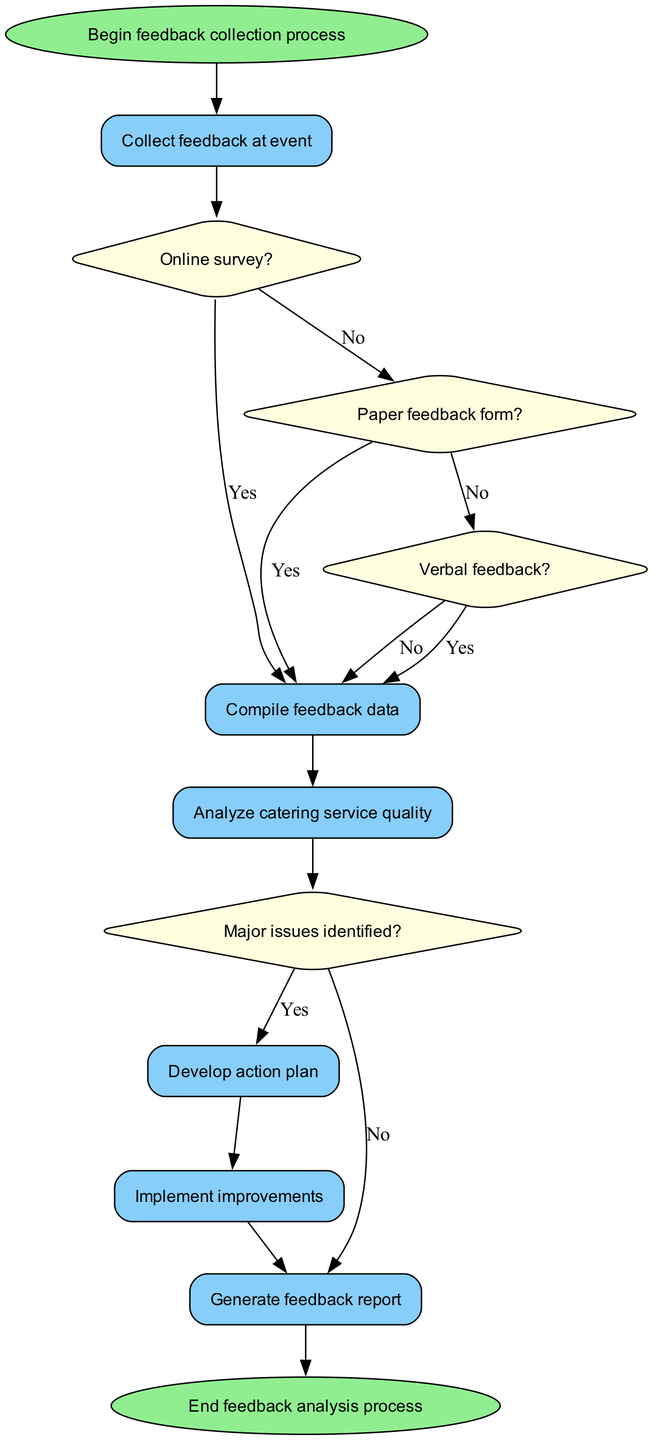What is the first step in the feedback collection process? The diagram starts with the node labeled "Begin feedback collection process," which indicates the initial action to take.
Answer: Begin feedback collection process How many methods are available for collecting feedback? The diagram lists three methods for collecting feedback: online survey, paper feedback form, and verbal feedback. By counting the methods, we find there are three distinct options.
Answer: 3 What happens if major issues are identified during the analysis? According to the flowchart, if major issues are identified, the next action taken is to develop an action plan, as indicated by the "Yes" label leading to the action node.
Answer: Develop action plan What is the process that follows the compilation of feedback data? After the "Compile feedback data" process, the next step is to "Analyze catering service quality," which is a direct connection in the flowchart.
Answer: Analyze catering service quality What are the two potential outcomes after analyzing the feedback? The analysis can lead to two outcomes: identifying major issues (leading to the development of an action plan) or not identifying major issues (leading to generating a feedback report). These outcomes are represented in the flowchart with "Yes" and "No" paths from the issues decision node.
Answer: Major issues identified or No major issues What is the last step in the feedback analysis process? The flowchart indicates that the final step of the process is to "End feedback analysis process," which is where the flow concludes.
Answer: End feedback analysis process If there is no online survey, which method follows next? If the decision for an online survey is "No," according to the flowchart, the next method considered is "Paper feedback form," as it represents the next decision node in the sequence.
Answer: Paper feedback form What is the decision node before developing an action plan? The decision node before developing an action plan is "Major issues identified?" which determines the flow to the action or report generation processes based on its outcome.
Answer: Major issues identified? 